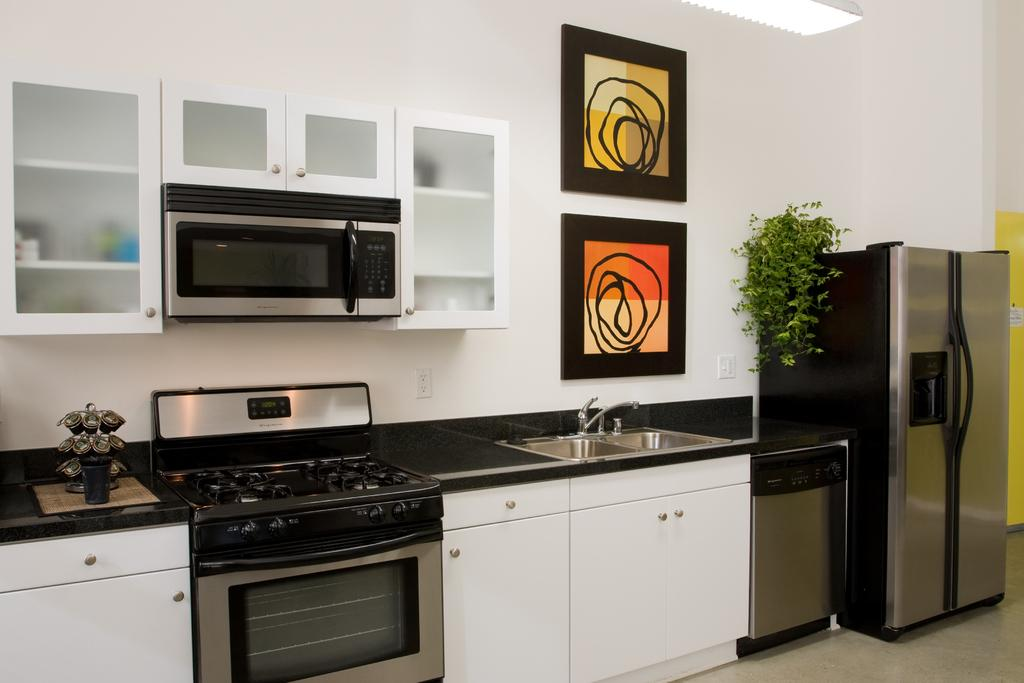What type of appliance can be seen in the image? There is a refrigerator in the image. What living organism is present in the image? There is a plant in the image. What is used for washing hands in the image? There is a wash basin and a water tap in the image. What is hung on the wall in the image? There are frames on the wall in the image. What type of cooking appliances are in the image? There is a stove and an oven in the image. What type of storage is available in the image? There are cupboards in the image. What are the main structural elements in the image? There is a wall and a floor in the image. How many knots are tied in the plant's leaves in the image? There are no knots present in the plant's leaves in the image. What type of fruit is hanging from the water tap in the image? There are no fruits present in the image, and the water tap is not associated with any hanging objects. 